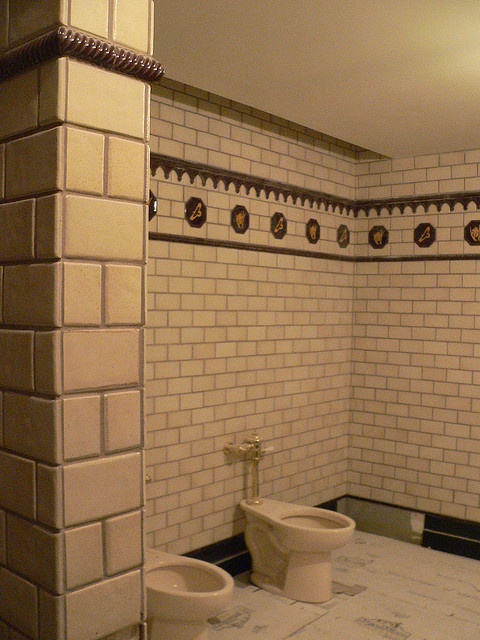Describe the objects in this image and their specific colors. I can see toilet in black, gray, olive, and tan tones and toilet in black, gray, tan, and olive tones in this image. 